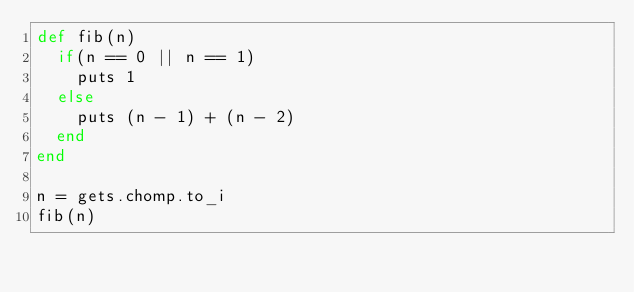Convert code to text. <code><loc_0><loc_0><loc_500><loc_500><_Ruby_>def fib(n)
	if(n == 0 || n == 1)
		puts 1
	else
		puts (n - 1) + (n - 2)
	end
end

n = gets.chomp.to_i
fib(n)</code> 